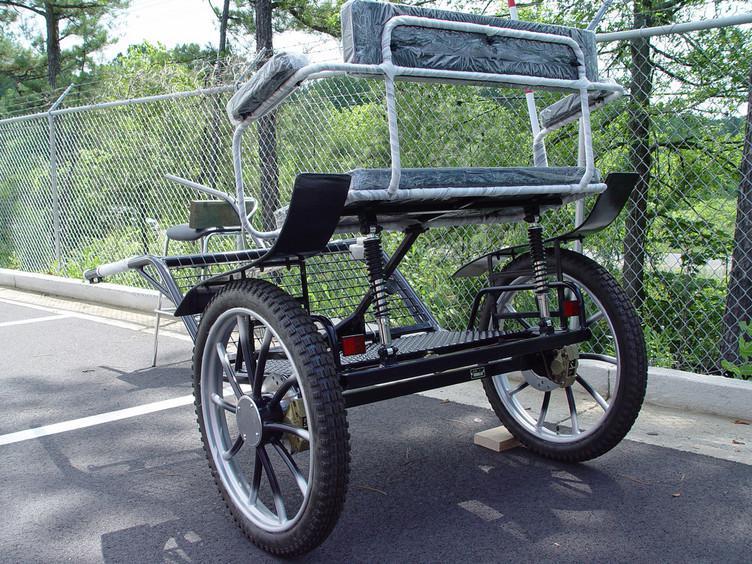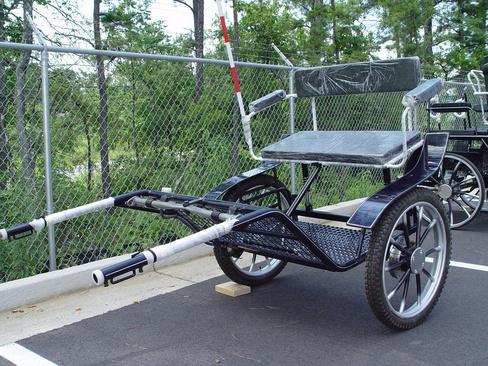The first image is the image on the left, the second image is the image on the right. Given the left and right images, does the statement "At least one carriage is being pulled by a horse." hold true? Answer yes or no. No. The first image is the image on the left, the second image is the image on the right. Examine the images to the left and right. Is the description "At least one buggy is attached to a horse." accurate? Answer yes or no. No. 